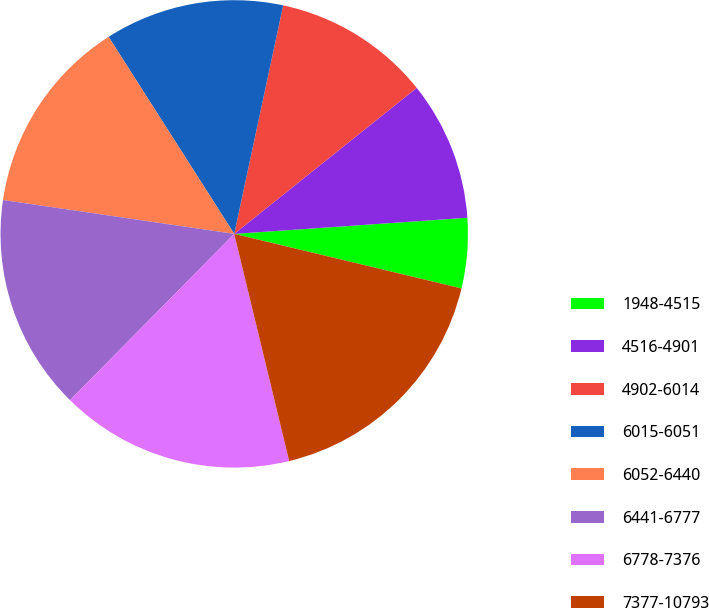Convert chart. <chart><loc_0><loc_0><loc_500><loc_500><pie_chart><fcel>1948-4515<fcel>4516-4901<fcel>4902-6014<fcel>6015-6051<fcel>6052-6440<fcel>6441-6777<fcel>6778-7376<fcel>7377-10793<nl><fcel>4.85%<fcel>9.64%<fcel>10.9%<fcel>12.39%<fcel>13.65%<fcel>14.91%<fcel>16.18%<fcel>17.47%<nl></chart> 